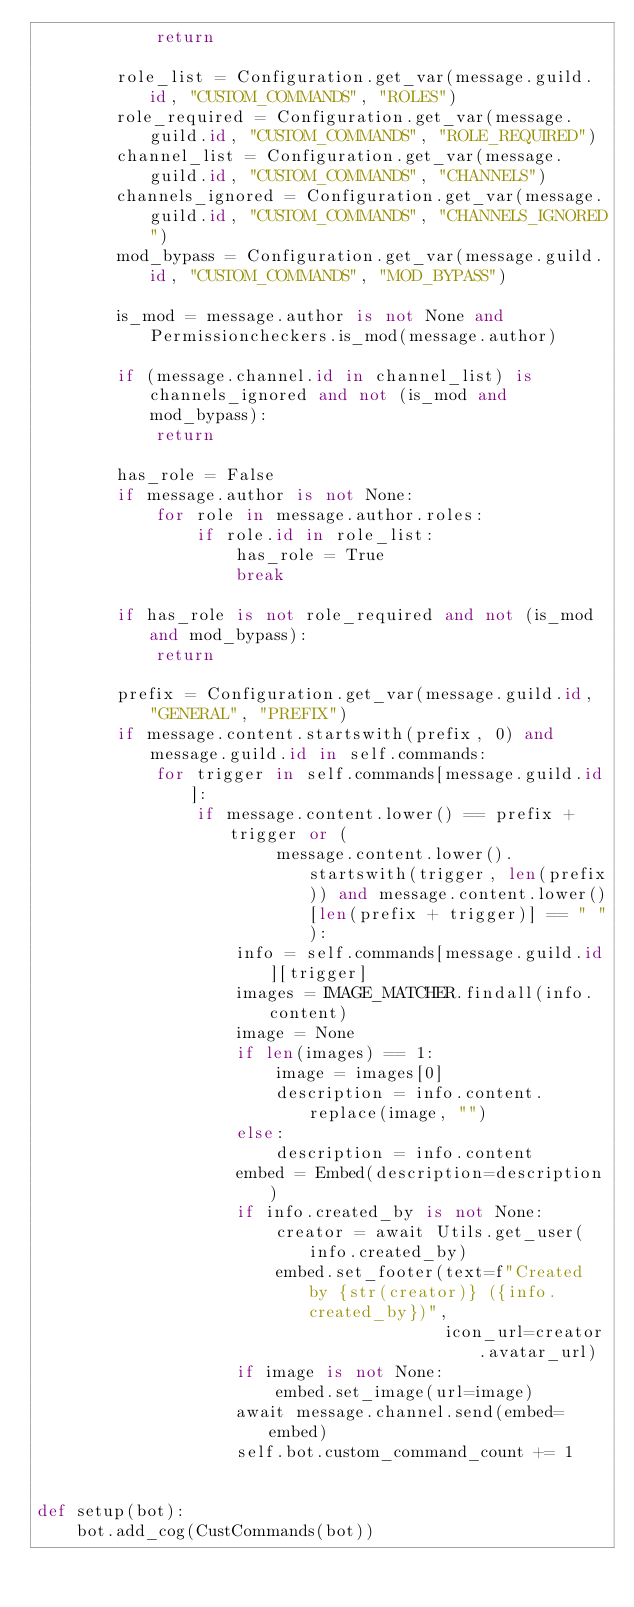<code> <loc_0><loc_0><loc_500><loc_500><_Python_>            return

        role_list = Configuration.get_var(message.guild.id, "CUSTOM_COMMANDS", "ROLES")
        role_required = Configuration.get_var(message.guild.id, "CUSTOM_COMMANDS", "ROLE_REQUIRED")
        channel_list = Configuration.get_var(message.guild.id, "CUSTOM_COMMANDS", "CHANNELS")
        channels_ignored = Configuration.get_var(message.guild.id, "CUSTOM_COMMANDS", "CHANNELS_IGNORED")
        mod_bypass = Configuration.get_var(message.guild.id, "CUSTOM_COMMANDS", "MOD_BYPASS")

        is_mod = message.author is not None and Permissioncheckers.is_mod(message.author)

        if (message.channel.id in channel_list) is channels_ignored and not (is_mod and mod_bypass):
            return

        has_role = False
        if message.author is not None:
            for role in message.author.roles:
                if role.id in role_list:
                    has_role = True
                    break

        if has_role is not role_required and not (is_mod and mod_bypass):
            return

        prefix = Configuration.get_var(message.guild.id, "GENERAL", "PREFIX")
        if message.content.startswith(prefix, 0) and message.guild.id in self.commands:
            for trigger in self.commands[message.guild.id]:
                if message.content.lower() == prefix + trigger or (
                        message.content.lower().startswith(trigger, len(prefix)) and message.content.lower()[len(prefix + trigger)] == " "):
                    info = self.commands[message.guild.id][trigger]
                    images = IMAGE_MATCHER.findall(info.content)
                    image = None
                    if len(images) == 1:
                        image = images[0]
                        description = info.content.replace(image, "")
                    else:
                        description = info.content
                    embed = Embed(description=description)
                    if info.created_by is not None:
                        creator = await Utils.get_user(info.created_by)
                        embed.set_footer(text=f"Created by {str(creator)} ({info.created_by})",
                                         icon_url=creator.avatar_url)
                    if image is not None:
                        embed.set_image(url=image)
                    await message.channel.send(embed=embed)
                    self.bot.custom_command_count += 1


def setup(bot):
    bot.add_cog(CustCommands(bot))
</code> 